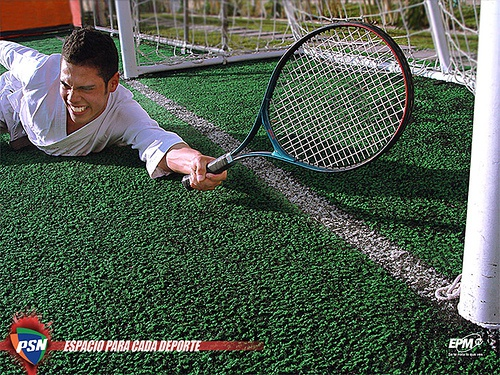Describe the objects in this image and their specific colors. I can see tennis racket in maroon, black, lightgray, gray, and darkgray tones and people in maroon, lavender, gray, black, and darkgray tones in this image. 